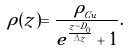<formula> <loc_0><loc_0><loc_500><loc_500>\rho ( z ) = \frac { \rho _ { _ { C u } } } { e ^ { \frac { z - D _ { 0 } } { \Delta z } } + 1 } .</formula> 